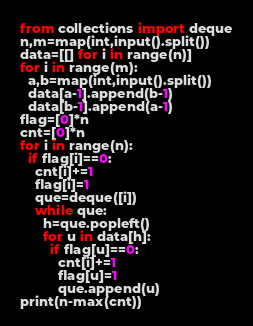<code> <loc_0><loc_0><loc_500><loc_500><_Python_>from collections import deque
n,m=map(int,input().split())
data=[[] for i in range(n)]
for i in range(m):
  a,b=map(int,input().split())
  data[a-1].append(b-1)
  data[b-1].append(a-1)
flag=[0]*n
cnt=[0]*n
for i in range(n):
  if flag[i]==0:
    cnt[i]+=1
    flag[i]=1
    que=deque([i])
    while que:
      h=que.popleft()
      for u in data[h]:
        if flag[u]==0:
          cnt[i]+=1
          flag[u]=1
          que.append(u)
print(n-max(cnt))</code> 